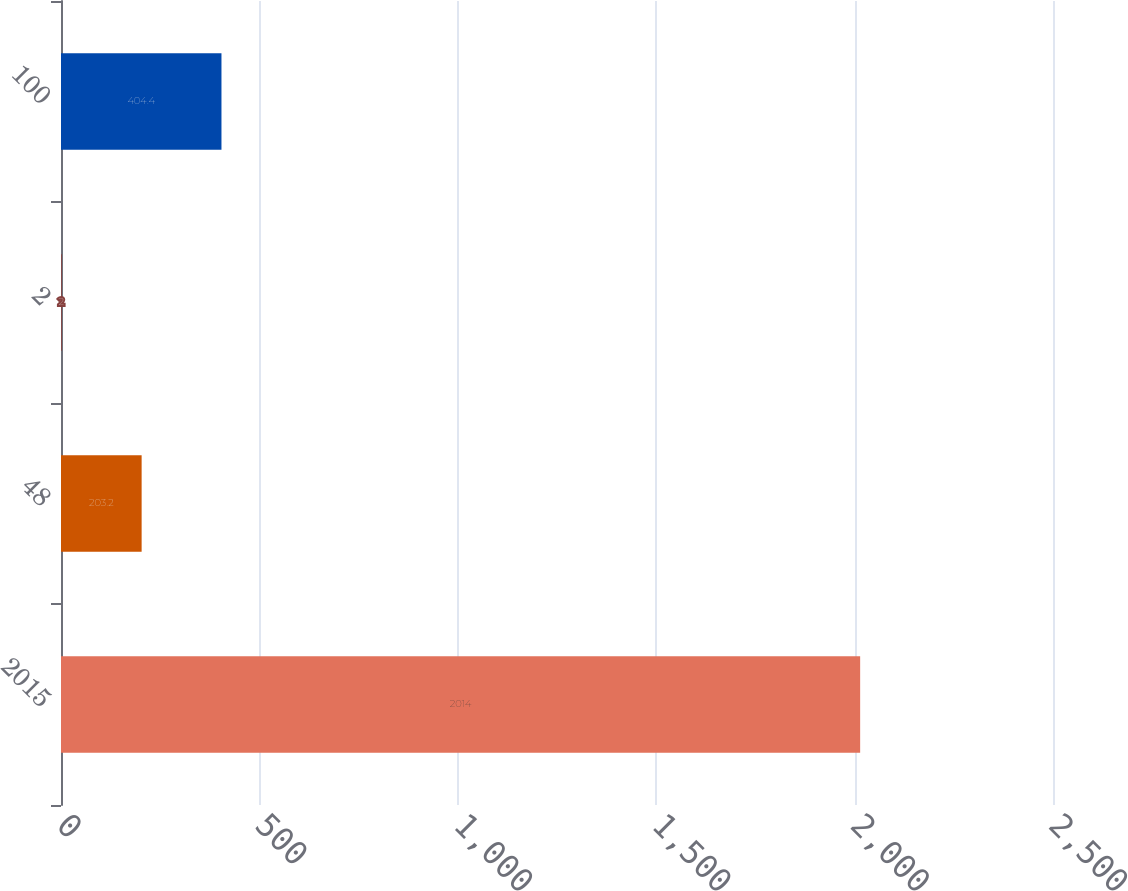<chart> <loc_0><loc_0><loc_500><loc_500><bar_chart><fcel>2015<fcel>48<fcel>2<fcel>100<nl><fcel>2014<fcel>203.2<fcel>2<fcel>404.4<nl></chart> 